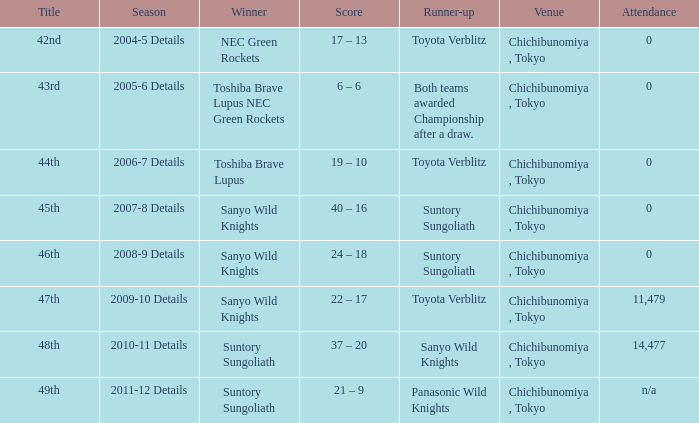What team was the winner when the runner-up shows both teams awarded championship after a draw.? Toshiba Brave Lupus NEC Green Rockets. 